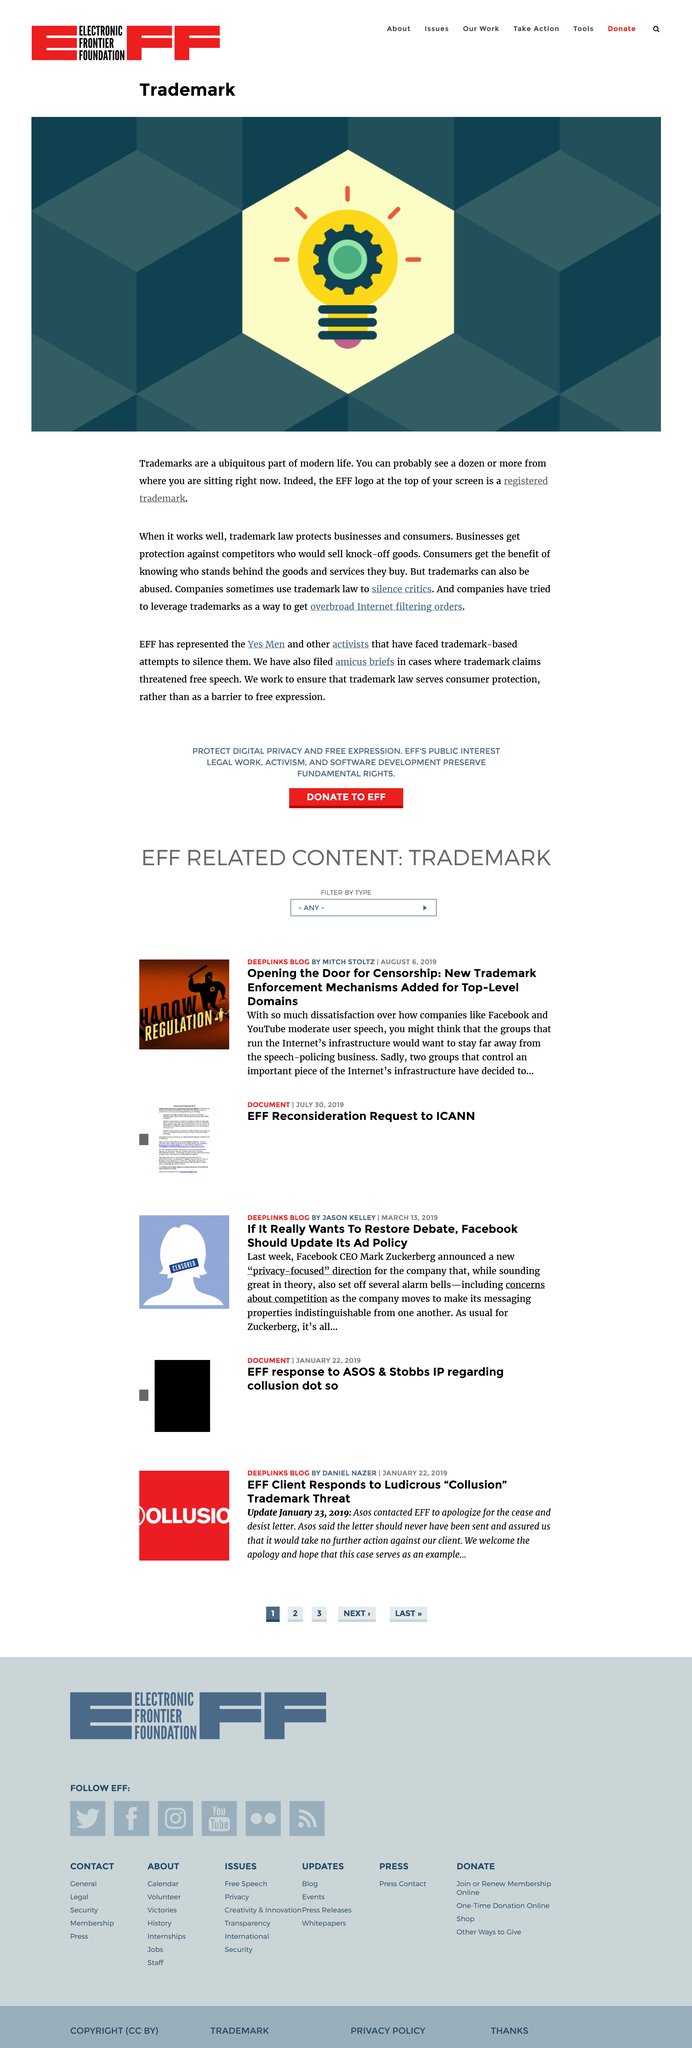Outline some significant characteristics in this image. This page pertains to Trademarks. Trademark law protects both businesses and consumers from infringement and misuse of their trademarks, ensuring the integrity and recognition of quality products and services. The title of the page is "Trademark" as declared. 